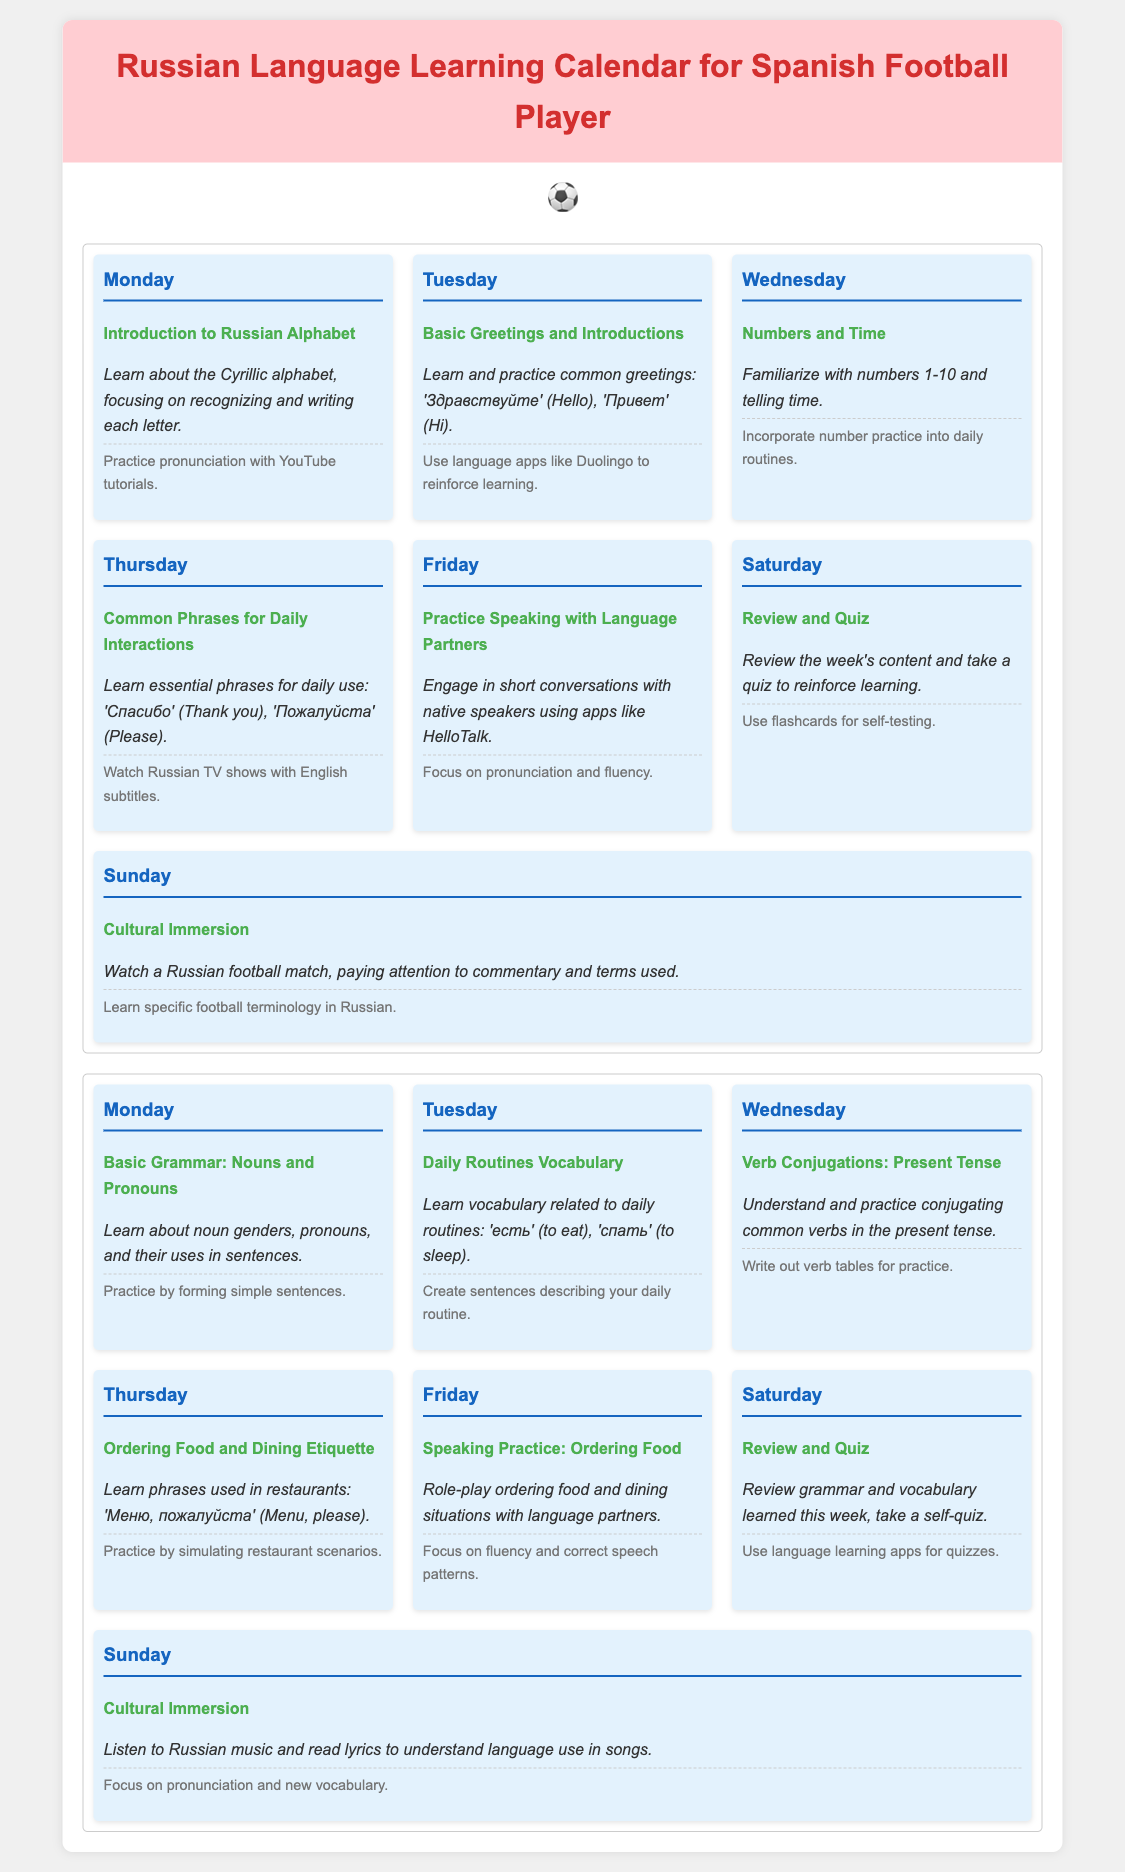What is learned on Monday of the first week? The document states that on Monday of the first week, the activity is "Introduction to Russian Alphabet," which focuses on recognizing and writing each letter.
Answer: Introduction to Russian Alphabet What common greeting is practiced on Tuesday? The document details that on Tuesday, the common greetings learned include "Здравствуйте" (Hello) and "Привет" (Hi).
Answer: Здравствуйте How many days are included in the language learning calendar? The document presents two weeks of activities, with each week comprising seven days, totaling fourteen days.
Answer: 14 days What essential phrase is taught on Thursday of the first week? According to the document, the essential phrase taught on Thursday of the first week is "Спасибо" (Thank you).
Answer: Спасибо What activity is scheduled for Sunday of the second week? The document specifies that the activity on Sunday of the second week is "Cultural Immersion," which involves listening to Russian music and reading lyrics.
Answer: Cultural Immersion What is the main focus of Saturday's activities in both weeks? The document indicates that Saturdays in both weeks are dedicated to "Review and Quiz" to reinforce learning.
Answer: Review and Quiz What vocabulary is learned on Tuesday of the second week? The activity on Tuesday of the second week revolves around "Daily Routines Vocabulary," focusing on verbs like 'есть' (to eat) and 'спать' (to sleep).
Answer: Daily Routines Vocabulary Which day emphasizes speaking practice with language partners? The document states that Friday is dedicated to the activity of "Practice Speaking with Language Partners," focusing on short conversations.
Answer: Friday 